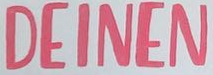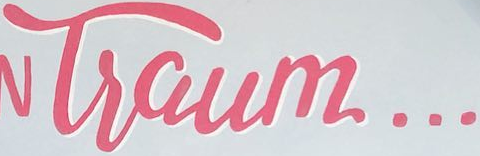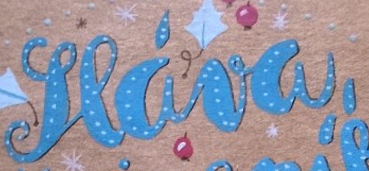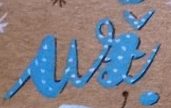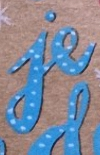Read the text content from these images in order, separated by a semicolon. DEINEN; Tsaum...; seáva,; ui; je 